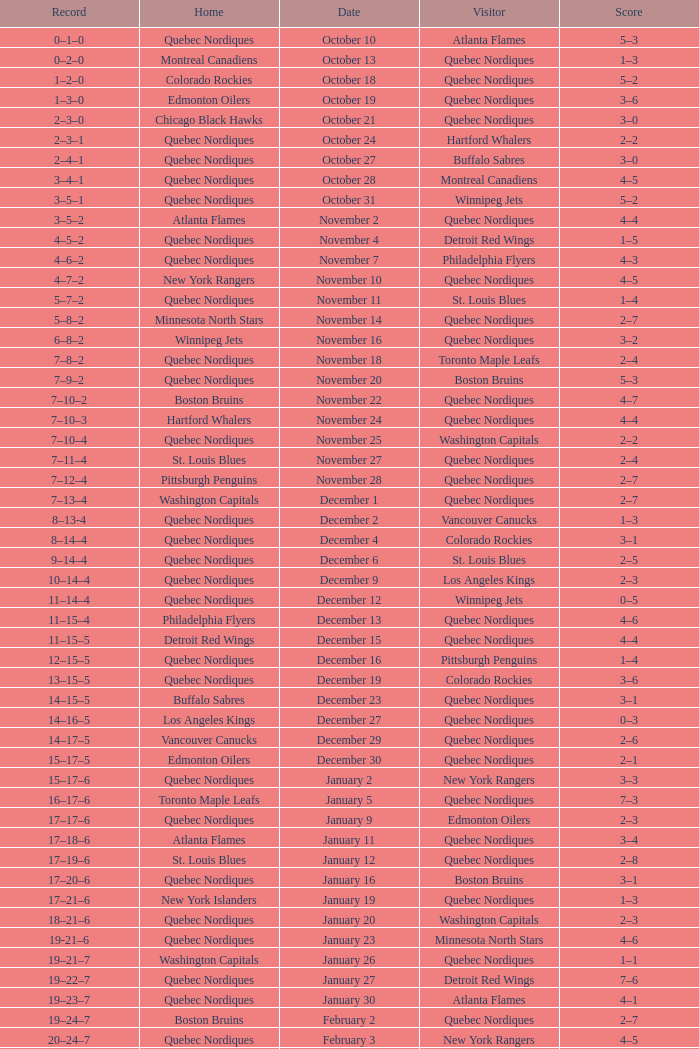Which Home has a Date of april 1? Quebec Nordiques. 